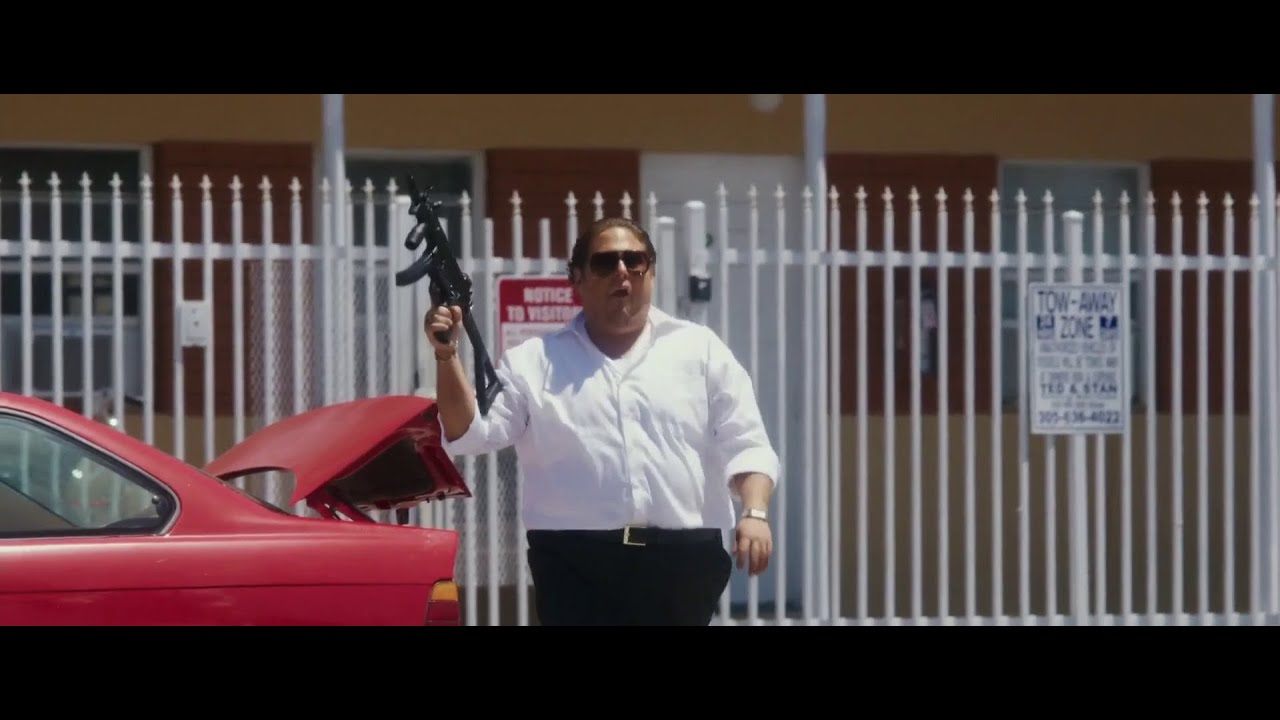Can you describe the main features of this image for me? In this image, a man is captured in motion near a red car, holding a black gun upwards which may suggest an action-packed scenario. He is dressed in a white short-sleeved shirt, beige pants, and dark sunglasses which confer a casual style contrasted by the intense action depicted. The background features a white fence displaying a 'NOTICE NO VISITORS' sign, hinting at a private or restricted area, which adds a layer of intrigue to the scene. A building with a reddish roof can be seen in the background that complements the car's color, making for a visually coordinated scene. 